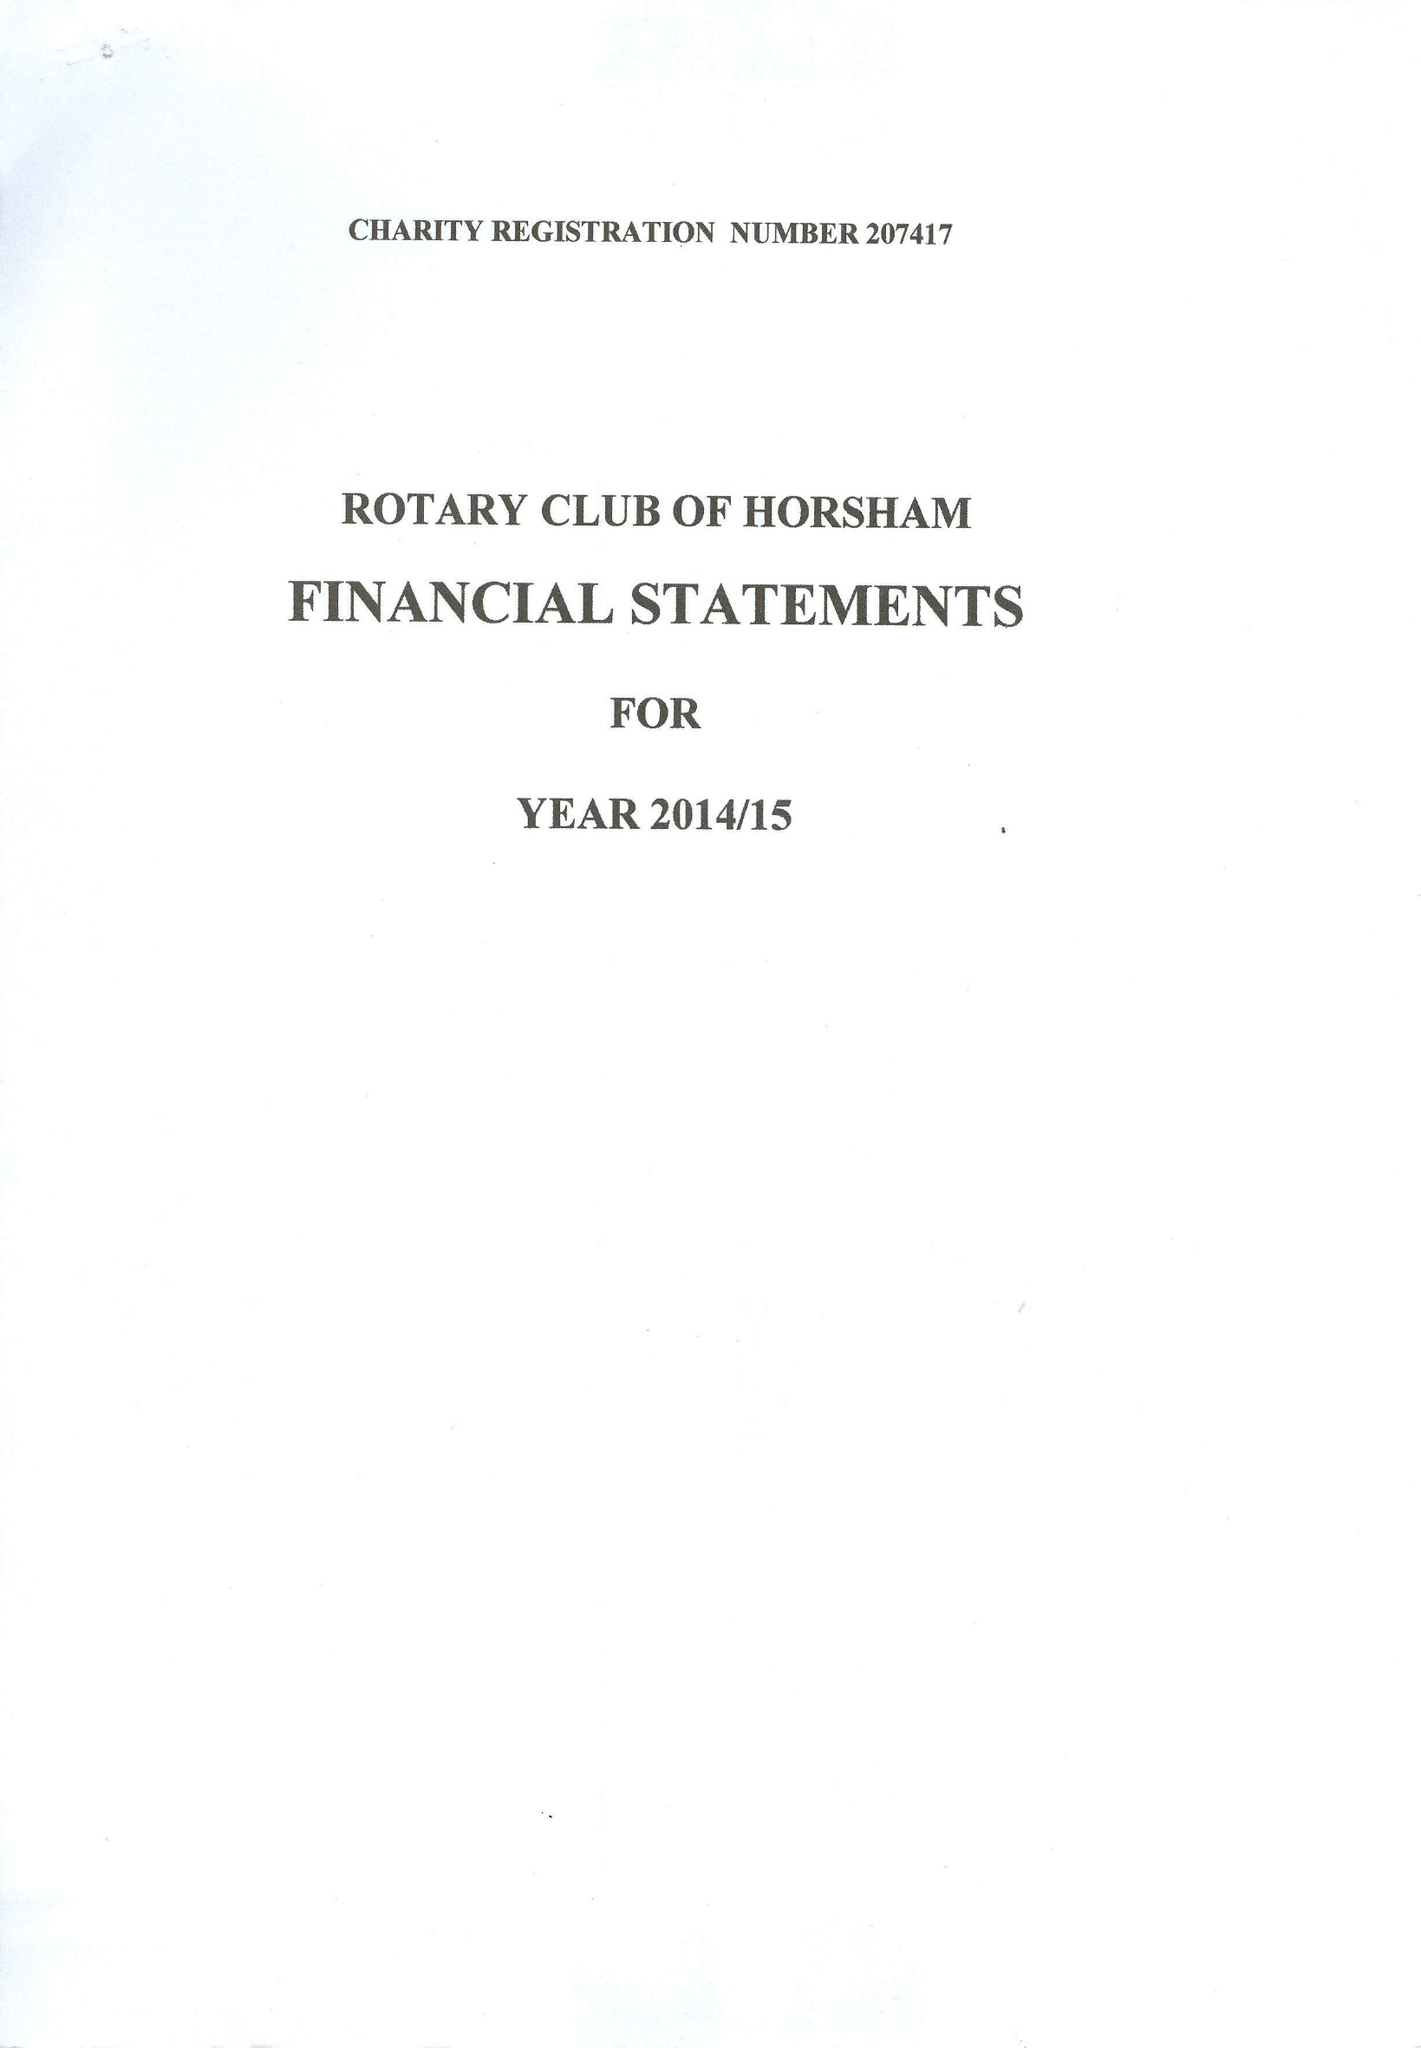What is the value for the address__street_line?
Answer the question using a single word or phrase. None 